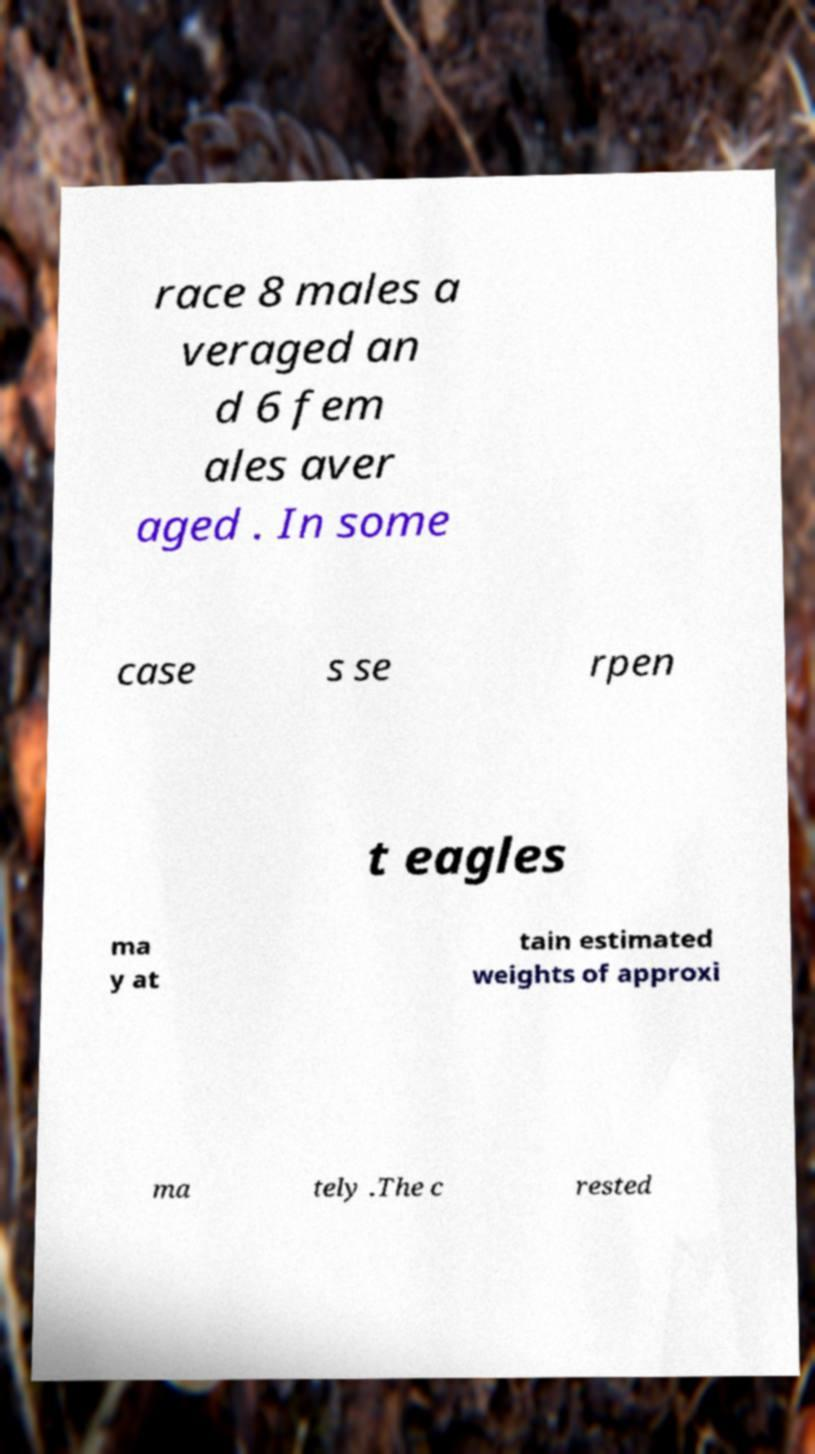What messages or text are displayed in this image? I need them in a readable, typed format. race 8 males a veraged an d 6 fem ales aver aged . In some case s se rpen t eagles ma y at tain estimated weights of approxi ma tely .The c rested 